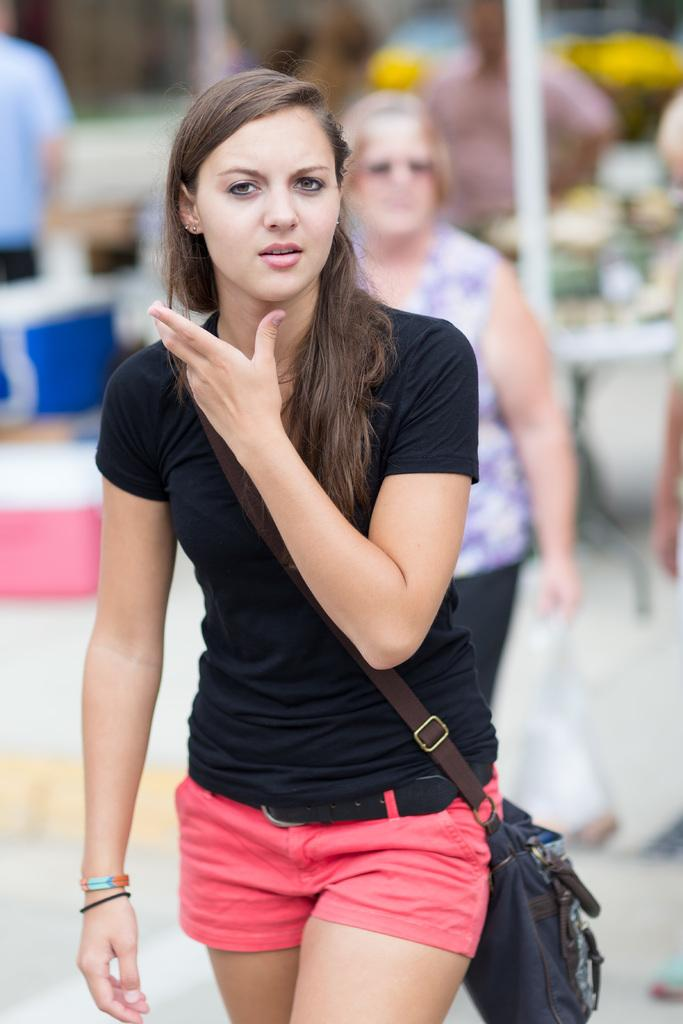What is the main subject of the image? There is a person in the image. What is the person doing in the image? The person is walking. Can you describe the background of the image? The background of the image is blurred. How many clovers can be seen growing in the background of the image? There are no clovers visible in the image, as the background is blurred and does not show any plants or vegetation. 